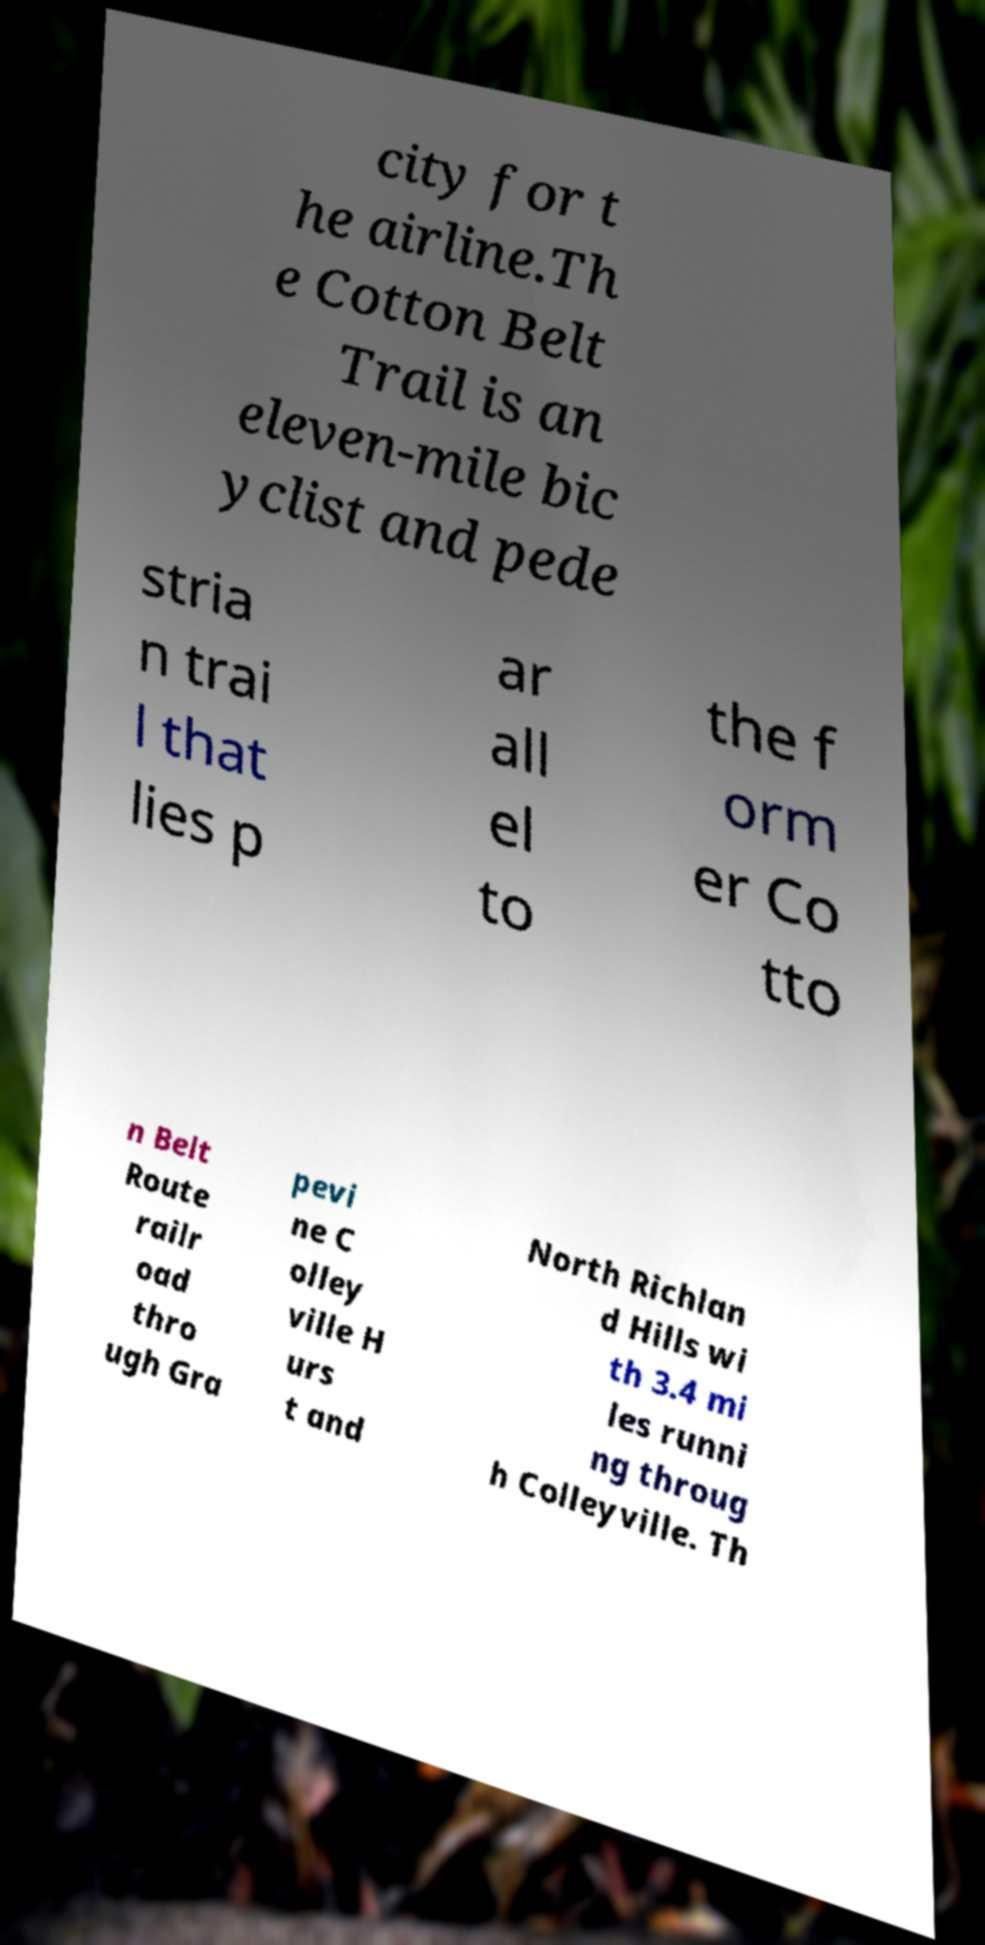There's text embedded in this image that I need extracted. Can you transcribe it verbatim? city for t he airline.Th e Cotton Belt Trail is an eleven-mile bic yclist and pede stria n trai l that lies p ar all el to the f orm er Co tto n Belt Route railr oad thro ugh Gra pevi ne C olley ville H urs t and North Richlan d Hills wi th 3.4 mi les runni ng throug h Colleyville. Th 